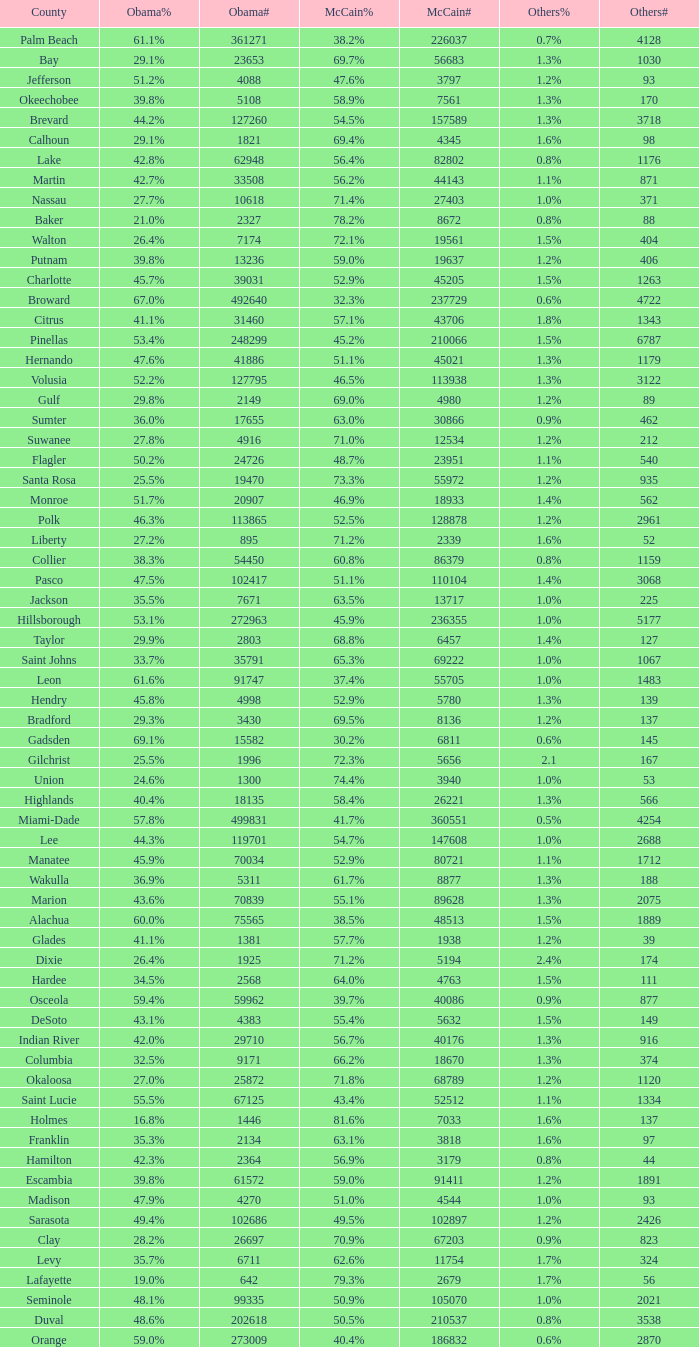What was the number of others votes in Columbia county? 374.0. Could you parse the entire table? {'header': ['County', 'Obama%', 'Obama#', 'McCain%', 'McCain#', 'Others%', 'Others#'], 'rows': [['Palm Beach', '61.1%', '361271', '38.2%', '226037', '0.7%', '4128'], ['Bay', '29.1%', '23653', '69.7%', '56683', '1.3%', '1030'], ['Jefferson', '51.2%', '4088', '47.6%', '3797', '1.2%', '93'], ['Okeechobee', '39.8%', '5108', '58.9%', '7561', '1.3%', '170'], ['Brevard', '44.2%', '127260', '54.5%', '157589', '1.3%', '3718'], ['Calhoun', '29.1%', '1821', '69.4%', '4345', '1.6%', '98'], ['Lake', '42.8%', '62948', '56.4%', '82802', '0.8%', '1176'], ['Martin', '42.7%', '33508', '56.2%', '44143', '1.1%', '871'], ['Nassau', '27.7%', '10618', '71.4%', '27403', '1.0%', '371'], ['Baker', '21.0%', '2327', '78.2%', '8672', '0.8%', '88'], ['Walton', '26.4%', '7174', '72.1%', '19561', '1.5%', '404'], ['Putnam', '39.8%', '13236', '59.0%', '19637', '1.2%', '406'], ['Charlotte', '45.7%', '39031', '52.9%', '45205', '1.5%', '1263'], ['Broward', '67.0%', '492640', '32.3%', '237729', '0.6%', '4722'], ['Citrus', '41.1%', '31460', '57.1%', '43706', '1.8%', '1343'], ['Pinellas', '53.4%', '248299', '45.2%', '210066', '1.5%', '6787'], ['Hernando', '47.6%', '41886', '51.1%', '45021', '1.3%', '1179'], ['Volusia', '52.2%', '127795', '46.5%', '113938', '1.3%', '3122'], ['Gulf', '29.8%', '2149', '69.0%', '4980', '1.2%', '89'], ['Sumter', '36.0%', '17655', '63.0%', '30866', '0.9%', '462'], ['Suwanee', '27.8%', '4916', '71.0%', '12534', '1.2%', '212'], ['Flagler', '50.2%', '24726', '48.7%', '23951', '1.1%', '540'], ['Santa Rosa', '25.5%', '19470', '73.3%', '55972', '1.2%', '935'], ['Monroe', '51.7%', '20907', '46.9%', '18933', '1.4%', '562'], ['Polk', '46.3%', '113865', '52.5%', '128878', '1.2%', '2961'], ['Liberty', '27.2%', '895', '71.2%', '2339', '1.6%', '52'], ['Collier', '38.3%', '54450', '60.8%', '86379', '0.8%', '1159'], ['Pasco', '47.5%', '102417', '51.1%', '110104', '1.4%', '3068'], ['Jackson', '35.5%', '7671', '63.5%', '13717', '1.0%', '225'], ['Hillsborough', '53.1%', '272963', '45.9%', '236355', '1.0%', '5177'], ['Taylor', '29.9%', '2803', '68.8%', '6457', '1.4%', '127'], ['Saint Johns', '33.7%', '35791', '65.3%', '69222', '1.0%', '1067'], ['Leon', '61.6%', '91747', '37.4%', '55705', '1.0%', '1483'], ['Hendry', '45.8%', '4998', '52.9%', '5780', '1.3%', '139'], ['Bradford', '29.3%', '3430', '69.5%', '8136', '1.2%', '137'], ['Gadsden', '69.1%', '15582', '30.2%', '6811', '0.6%', '145'], ['Gilchrist', '25.5%', '1996', '72.3%', '5656', '2.1', '167'], ['Union', '24.6%', '1300', '74.4%', '3940', '1.0%', '53'], ['Highlands', '40.4%', '18135', '58.4%', '26221', '1.3%', '566'], ['Miami-Dade', '57.8%', '499831', '41.7%', '360551', '0.5%', '4254'], ['Lee', '44.3%', '119701', '54.7%', '147608', '1.0%', '2688'], ['Manatee', '45.9%', '70034', '52.9%', '80721', '1.1%', '1712'], ['Wakulla', '36.9%', '5311', '61.7%', '8877', '1.3%', '188'], ['Marion', '43.6%', '70839', '55.1%', '89628', '1.3%', '2075'], ['Alachua', '60.0%', '75565', '38.5%', '48513', '1.5%', '1889'], ['Glades', '41.1%', '1381', '57.7%', '1938', '1.2%', '39'], ['Dixie', '26.4%', '1925', '71.2%', '5194', '2.4%', '174'], ['Hardee', '34.5%', '2568', '64.0%', '4763', '1.5%', '111'], ['Osceola', '59.4%', '59962', '39.7%', '40086', '0.9%', '877'], ['DeSoto', '43.1%', '4383', '55.4%', '5632', '1.5%', '149'], ['Indian River', '42.0%', '29710', '56.7%', '40176', '1.3%', '916'], ['Columbia', '32.5%', '9171', '66.2%', '18670', '1.3%', '374'], ['Okaloosa', '27.0%', '25872', '71.8%', '68789', '1.2%', '1120'], ['Saint Lucie', '55.5%', '67125', '43.4%', '52512', '1.1%', '1334'], ['Holmes', '16.8%', '1446', '81.6%', '7033', '1.6%', '137'], ['Franklin', '35.3%', '2134', '63.1%', '3818', '1.6%', '97'], ['Hamilton', '42.3%', '2364', '56.9%', '3179', '0.8%', '44'], ['Escambia', '39.8%', '61572', '59.0%', '91411', '1.2%', '1891'], ['Madison', '47.9%', '4270', '51.0%', '4544', '1.0%', '93'], ['Sarasota', '49.4%', '102686', '49.5%', '102897', '1.2%', '2426'], ['Clay', '28.2%', '26697', '70.9%', '67203', '0.9%', '823'], ['Levy', '35.7%', '6711', '62.6%', '11754', '1.7%', '324'], ['Lafayette', '19.0%', '642', '79.3%', '2679', '1.7%', '56'], ['Seminole', '48.1%', '99335', '50.9%', '105070', '1.0%', '2021'], ['Duval', '48.6%', '202618', '50.5%', '210537', '0.8%', '3538'], ['Orange', '59.0%', '273009', '40.4%', '186832', '0.6%', '2870']]} 